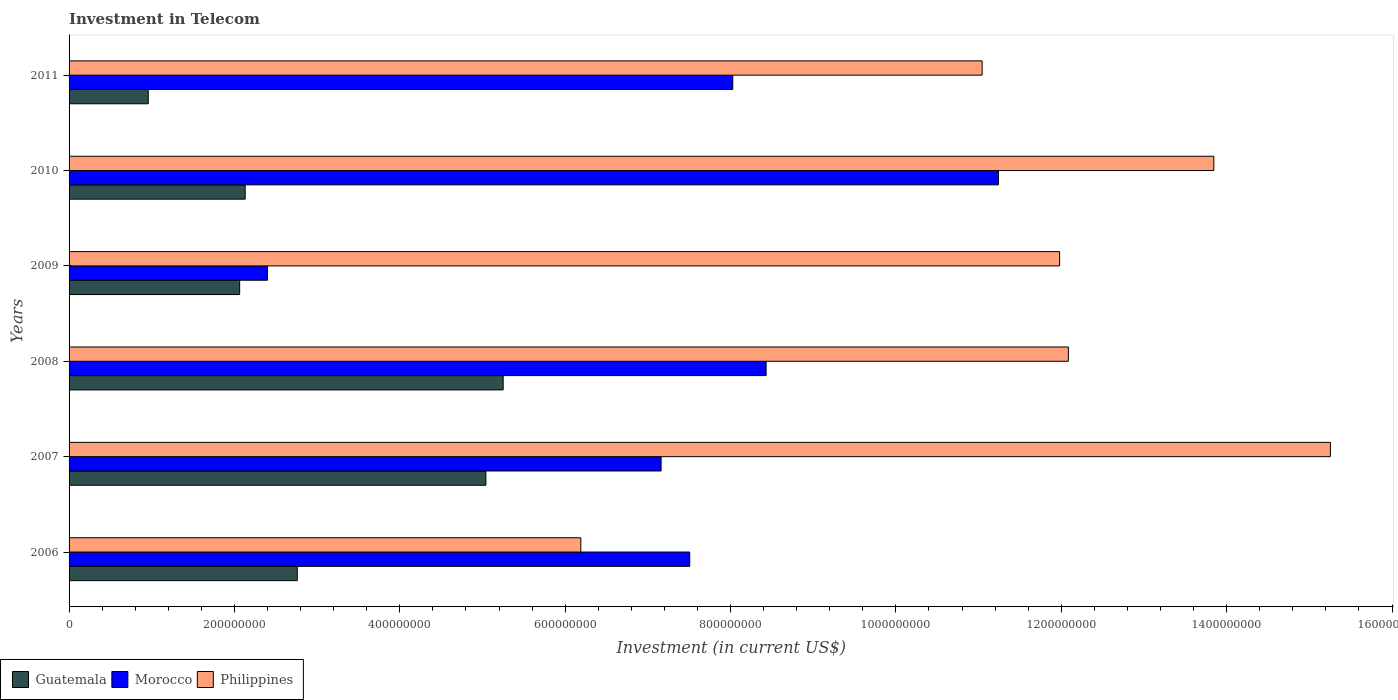Are the number of bars per tick equal to the number of legend labels?
Provide a short and direct response. Yes. How many bars are there on the 6th tick from the bottom?
Your response must be concise. 3. What is the label of the 3rd group of bars from the top?
Keep it short and to the point. 2009. In how many cases, is the number of bars for a given year not equal to the number of legend labels?
Provide a succinct answer. 0. What is the amount invested in telecom in Morocco in 2009?
Your answer should be compact. 2.40e+08. Across all years, what is the maximum amount invested in telecom in Philippines?
Your answer should be very brief. 1.53e+09. Across all years, what is the minimum amount invested in telecom in Morocco?
Provide a succinct answer. 2.40e+08. In which year was the amount invested in telecom in Philippines minimum?
Your answer should be compact. 2006. What is the total amount invested in telecom in Morocco in the graph?
Offer a very short reply. 4.48e+09. What is the difference between the amount invested in telecom in Philippines in 2010 and that in 2011?
Keep it short and to the point. 2.80e+08. What is the difference between the amount invested in telecom in Philippines in 2009 and the amount invested in telecom in Morocco in 2008?
Your response must be concise. 3.55e+08. What is the average amount invested in telecom in Morocco per year?
Keep it short and to the point. 7.46e+08. In the year 2006, what is the difference between the amount invested in telecom in Guatemala and amount invested in telecom in Morocco?
Offer a very short reply. -4.75e+08. In how many years, is the amount invested in telecom in Morocco greater than 1400000000 US$?
Keep it short and to the point. 0. What is the ratio of the amount invested in telecom in Guatemala in 2006 to that in 2007?
Your answer should be very brief. 0.55. Is the amount invested in telecom in Philippines in 2008 less than that in 2009?
Provide a short and direct response. No. What is the difference between the highest and the second highest amount invested in telecom in Guatemala?
Offer a very short reply. 2.09e+07. What is the difference between the highest and the lowest amount invested in telecom in Guatemala?
Your response must be concise. 4.29e+08. In how many years, is the amount invested in telecom in Philippines greater than the average amount invested in telecom in Philippines taken over all years?
Provide a succinct answer. 4. Is the sum of the amount invested in telecom in Morocco in 2008 and 2010 greater than the maximum amount invested in telecom in Guatemala across all years?
Provide a short and direct response. Yes. What does the 2nd bar from the top in 2007 represents?
Give a very brief answer. Morocco. What does the 1st bar from the bottom in 2009 represents?
Offer a terse response. Guatemala. How many bars are there?
Keep it short and to the point. 18. Are all the bars in the graph horizontal?
Keep it short and to the point. Yes. How many years are there in the graph?
Ensure brevity in your answer.  6. What is the difference between two consecutive major ticks on the X-axis?
Your answer should be very brief. 2.00e+08. Are the values on the major ticks of X-axis written in scientific E-notation?
Ensure brevity in your answer.  No. Does the graph contain any zero values?
Make the answer very short. No. Does the graph contain grids?
Your response must be concise. No. Where does the legend appear in the graph?
Your answer should be very brief. Bottom left. How are the legend labels stacked?
Your answer should be very brief. Horizontal. What is the title of the graph?
Your answer should be very brief. Investment in Telecom. Does "San Marino" appear as one of the legend labels in the graph?
Your answer should be very brief. No. What is the label or title of the X-axis?
Your response must be concise. Investment (in current US$). What is the Investment (in current US$) in Guatemala in 2006?
Make the answer very short. 2.76e+08. What is the Investment (in current US$) in Morocco in 2006?
Keep it short and to the point. 7.51e+08. What is the Investment (in current US$) of Philippines in 2006?
Provide a succinct answer. 6.19e+08. What is the Investment (in current US$) in Guatemala in 2007?
Make the answer very short. 5.04e+08. What is the Investment (in current US$) of Morocco in 2007?
Ensure brevity in your answer.  7.16e+08. What is the Investment (in current US$) of Philippines in 2007?
Your answer should be compact. 1.53e+09. What is the Investment (in current US$) in Guatemala in 2008?
Your answer should be compact. 5.25e+08. What is the Investment (in current US$) of Morocco in 2008?
Ensure brevity in your answer.  8.43e+08. What is the Investment (in current US$) of Philippines in 2008?
Provide a succinct answer. 1.21e+09. What is the Investment (in current US$) of Guatemala in 2009?
Provide a succinct answer. 2.06e+08. What is the Investment (in current US$) of Morocco in 2009?
Ensure brevity in your answer.  2.40e+08. What is the Investment (in current US$) in Philippines in 2009?
Provide a succinct answer. 1.20e+09. What is the Investment (in current US$) in Guatemala in 2010?
Ensure brevity in your answer.  2.13e+08. What is the Investment (in current US$) of Morocco in 2010?
Your answer should be very brief. 1.12e+09. What is the Investment (in current US$) of Philippines in 2010?
Ensure brevity in your answer.  1.38e+09. What is the Investment (in current US$) of Guatemala in 2011?
Give a very brief answer. 9.58e+07. What is the Investment (in current US$) of Morocco in 2011?
Ensure brevity in your answer.  8.03e+08. What is the Investment (in current US$) in Philippines in 2011?
Provide a short and direct response. 1.10e+09. Across all years, what is the maximum Investment (in current US$) of Guatemala?
Ensure brevity in your answer.  5.25e+08. Across all years, what is the maximum Investment (in current US$) of Morocco?
Offer a very short reply. 1.12e+09. Across all years, what is the maximum Investment (in current US$) in Philippines?
Your answer should be compact. 1.53e+09. Across all years, what is the minimum Investment (in current US$) in Guatemala?
Make the answer very short. 9.58e+07. Across all years, what is the minimum Investment (in current US$) in Morocco?
Keep it short and to the point. 2.40e+08. Across all years, what is the minimum Investment (in current US$) of Philippines?
Make the answer very short. 6.19e+08. What is the total Investment (in current US$) of Guatemala in the graph?
Your answer should be compact. 1.82e+09. What is the total Investment (in current US$) in Morocco in the graph?
Ensure brevity in your answer.  4.48e+09. What is the total Investment (in current US$) of Philippines in the graph?
Your answer should be very brief. 7.04e+09. What is the difference between the Investment (in current US$) in Guatemala in 2006 and that in 2007?
Provide a short and direct response. -2.28e+08. What is the difference between the Investment (in current US$) of Morocco in 2006 and that in 2007?
Make the answer very short. 3.46e+07. What is the difference between the Investment (in current US$) in Philippines in 2006 and that in 2007?
Offer a very short reply. -9.07e+08. What is the difference between the Investment (in current US$) of Guatemala in 2006 and that in 2008?
Make the answer very short. -2.49e+08. What is the difference between the Investment (in current US$) of Morocco in 2006 and that in 2008?
Offer a terse response. -9.24e+07. What is the difference between the Investment (in current US$) of Philippines in 2006 and that in 2008?
Your response must be concise. -5.90e+08. What is the difference between the Investment (in current US$) in Guatemala in 2006 and that in 2009?
Keep it short and to the point. 6.97e+07. What is the difference between the Investment (in current US$) of Morocco in 2006 and that in 2009?
Give a very brief answer. 5.11e+08. What is the difference between the Investment (in current US$) of Philippines in 2006 and that in 2009?
Offer a very short reply. -5.79e+08. What is the difference between the Investment (in current US$) of Guatemala in 2006 and that in 2010?
Your answer should be compact. 6.30e+07. What is the difference between the Investment (in current US$) in Morocco in 2006 and that in 2010?
Provide a succinct answer. -3.73e+08. What is the difference between the Investment (in current US$) of Philippines in 2006 and that in 2010?
Keep it short and to the point. -7.66e+08. What is the difference between the Investment (in current US$) of Guatemala in 2006 and that in 2011?
Ensure brevity in your answer.  1.80e+08. What is the difference between the Investment (in current US$) of Morocco in 2006 and that in 2011?
Offer a terse response. -5.21e+07. What is the difference between the Investment (in current US$) in Philippines in 2006 and that in 2011?
Make the answer very short. -4.85e+08. What is the difference between the Investment (in current US$) in Guatemala in 2007 and that in 2008?
Offer a terse response. -2.09e+07. What is the difference between the Investment (in current US$) in Morocco in 2007 and that in 2008?
Give a very brief answer. -1.27e+08. What is the difference between the Investment (in current US$) of Philippines in 2007 and that in 2008?
Offer a terse response. 3.17e+08. What is the difference between the Investment (in current US$) of Guatemala in 2007 and that in 2009?
Ensure brevity in your answer.  2.98e+08. What is the difference between the Investment (in current US$) of Morocco in 2007 and that in 2009?
Provide a succinct answer. 4.76e+08. What is the difference between the Investment (in current US$) of Philippines in 2007 and that in 2009?
Provide a succinct answer. 3.28e+08. What is the difference between the Investment (in current US$) in Guatemala in 2007 and that in 2010?
Provide a succinct answer. 2.91e+08. What is the difference between the Investment (in current US$) of Morocco in 2007 and that in 2010?
Provide a short and direct response. -4.08e+08. What is the difference between the Investment (in current US$) in Philippines in 2007 and that in 2010?
Give a very brief answer. 1.41e+08. What is the difference between the Investment (in current US$) of Guatemala in 2007 and that in 2011?
Ensure brevity in your answer.  4.08e+08. What is the difference between the Investment (in current US$) in Morocco in 2007 and that in 2011?
Provide a short and direct response. -8.67e+07. What is the difference between the Investment (in current US$) of Philippines in 2007 and that in 2011?
Ensure brevity in your answer.  4.21e+08. What is the difference between the Investment (in current US$) in Guatemala in 2008 and that in 2009?
Your response must be concise. 3.19e+08. What is the difference between the Investment (in current US$) in Morocco in 2008 and that in 2009?
Offer a terse response. 6.03e+08. What is the difference between the Investment (in current US$) in Philippines in 2008 and that in 2009?
Your response must be concise. 1.06e+07. What is the difference between the Investment (in current US$) of Guatemala in 2008 and that in 2010?
Offer a terse response. 3.12e+08. What is the difference between the Investment (in current US$) of Morocco in 2008 and that in 2010?
Keep it short and to the point. -2.81e+08. What is the difference between the Investment (in current US$) in Philippines in 2008 and that in 2010?
Your answer should be very brief. -1.76e+08. What is the difference between the Investment (in current US$) in Guatemala in 2008 and that in 2011?
Your answer should be compact. 4.29e+08. What is the difference between the Investment (in current US$) in Morocco in 2008 and that in 2011?
Give a very brief answer. 4.03e+07. What is the difference between the Investment (in current US$) of Philippines in 2008 and that in 2011?
Give a very brief answer. 1.04e+08. What is the difference between the Investment (in current US$) in Guatemala in 2009 and that in 2010?
Keep it short and to the point. -6.70e+06. What is the difference between the Investment (in current US$) of Morocco in 2009 and that in 2010?
Your response must be concise. -8.84e+08. What is the difference between the Investment (in current US$) of Philippines in 2009 and that in 2010?
Offer a terse response. -1.86e+08. What is the difference between the Investment (in current US$) of Guatemala in 2009 and that in 2011?
Your answer should be compact. 1.10e+08. What is the difference between the Investment (in current US$) in Morocco in 2009 and that in 2011?
Provide a short and direct response. -5.63e+08. What is the difference between the Investment (in current US$) of Philippines in 2009 and that in 2011?
Ensure brevity in your answer.  9.37e+07. What is the difference between the Investment (in current US$) in Guatemala in 2010 and that in 2011?
Provide a short and direct response. 1.17e+08. What is the difference between the Investment (in current US$) in Morocco in 2010 and that in 2011?
Your answer should be very brief. 3.21e+08. What is the difference between the Investment (in current US$) in Philippines in 2010 and that in 2011?
Ensure brevity in your answer.  2.80e+08. What is the difference between the Investment (in current US$) of Guatemala in 2006 and the Investment (in current US$) of Morocco in 2007?
Offer a very short reply. -4.40e+08. What is the difference between the Investment (in current US$) of Guatemala in 2006 and the Investment (in current US$) of Philippines in 2007?
Offer a very short reply. -1.25e+09. What is the difference between the Investment (in current US$) of Morocco in 2006 and the Investment (in current US$) of Philippines in 2007?
Provide a short and direct response. -7.75e+08. What is the difference between the Investment (in current US$) of Guatemala in 2006 and the Investment (in current US$) of Morocco in 2008?
Offer a very short reply. -5.67e+08. What is the difference between the Investment (in current US$) in Guatemala in 2006 and the Investment (in current US$) in Philippines in 2008?
Keep it short and to the point. -9.33e+08. What is the difference between the Investment (in current US$) in Morocco in 2006 and the Investment (in current US$) in Philippines in 2008?
Provide a short and direct response. -4.58e+08. What is the difference between the Investment (in current US$) of Guatemala in 2006 and the Investment (in current US$) of Morocco in 2009?
Your answer should be compact. 3.60e+07. What is the difference between the Investment (in current US$) of Guatemala in 2006 and the Investment (in current US$) of Philippines in 2009?
Keep it short and to the point. -9.22e+08. What is the difference between the Investment (in current US$) of Morocco in 2006 and the Investment (in current US$) of Philippines in 2009?
Give a very brief answer. -4.47e+08. What is the difference between the Investment (in current US$) in Guatemala in 2006 and the Investment (in current US$) in Morocco in 2010?
Offer a very short reply. -8.48e+08. What is the difference between the Investment (in current US$) of Guatemala in 2006 and the Investment (in current US$) of Philippines in 2010?
Your response must be concise. -1.11e+09. What is the difference between the Investment (in current US$) of Morocco in 2006 and the Investment (in current US$) of Philippines in 2010?
Provide a succinct answer. -6.34e+08. What is the difference between the Investment (in current US$) of Guatemala in 2006 and the Investment (in current US$) of Morocco in 2011?
Give a very brief answer. -5.27e+08. What is the difference between the Investment (in current US$) in Guatemala in 2006 and the Investment (in current US$) in Philippines in 2011?
Your answer should be compact. -8.28e+08. What is the difference between the Investment (in current US$) in Morocco in 2006 and the Investment (in current US$) in Philippines in 2011?
Your answer should be very brief. -3.54e+08. What is the difference between the Investment (in current US$) in Guatemala in 2007 and the Investment (in current US$) in Morocco in 2008?
Provide a succinct answer. -3.39e+08. What is the difference between the Investment (in current US$) in Guatemala in 2007 and the Investment (in current US$) in Philippines in 2008?
Your answer should be compact. -7.04e+08. What is the difference between the Investment (in current US$) in Morocco in 2007 and the Investment (in current US$) in Philippines in 2008?
Make the answer very short. -4.93e+08. What is the difference between the Investment (in current US$) of Guatemala in 2007 and the Investment (in current US$) of Morocco in 2009?
Provide a short and direct response. 2.64e+08. What is the difference between the Investment (in current US$) of Guatemala in 2007 and the Investment (in current US$) of Philippines in 2009?
Your response must be concise. -6.94e+08. What is the difference between the Investment (in current US$) of Morocco in 2007 and the Investment (in current US$) of Philippines in 2009?
Provide a succinct answer. -4.82e+08. What is the difference between the Investment (in current US$) of Guatemala in 2007 and the Investment (in current US$) of Morocco in 2010?
Ensure brevity in your answer.  -6.20e+08. What is the difference between the Investment (in current US$) in Guatemala in 2007 and the Investment (in current US$) in Philippines in 2010?
Keep it short and to the point. -8.80e+08. What is the difference between the Investment (in current US$) in Morocco in 2007 and the Investment (in current US$) in Philippines in 2010?
Your answer should be compact. -6.68e+08. What is the difference between the Investment (in current US$) in Guatemala in 2007 and the Investment (in current US$) in Morocco in 2011?
Keep it short and to the point. -2.99e+08. What is the difference between the Investment (in current US$) in Guatemala in 2007 and the Investment (in current US$) in Philippines in 2011?
Give a very brief answer. -6.00e+08. What is the difference between the Investment (in current US$) in Morocco in 2007 and the Investment (in current US$) in Philippines in 2011?
Your answer should be compact. -3.88e+08. What is the difference between the Investment (in current US$) of Guatemala in 2008 and the Investment (in current US$) of Morocco in 2009?
Ensure brevity in your answer.  2.85e+08. What is the difference between the Investment (in current US$) of Guatemala in 2008 and the Investment (in current US$) of Philippines in 2009?
Provide a succinct answer. -6.73e+08. What is the difference between the Investment (in current US$) of Morocco in 2008 and the Investment (in current US$) of Philippines in 2009?
Ensure brevity in your answer.  -3.55e+08. What is the difference between the Investment (in current US$) in Guatemala in 2008 and the Investment (in current US$) in Morocco in 2010?
Make the answer very short. -5.99e+08. What is the difference between the Investment (in current US$) in Guatemala in 2008 and the Investment (in current US$) in Philippines in 2010?
Offer a very short reply. -8.60e+08. What is the difference between the Investment (in current US$) of Morocco in 2008 and the Investment (in current US$) of Philippines in 2010?
Provide a short and direct response. -5.42e+08. What is the difference between the Investment (in current US$) of Guatemala in 2008 and the Investment (in current US$) of Morocco in 2011?
Offer a terse response. -2.78e+08. What is the difference between the Investment (in current US$) in Guatemala in 2008 and the Investment (in current US$) in Philippines in 2011?
Your response must be concise. -5.79e+08. What is the difference between the Investment (in current US$) in Morocco in 2008 and the Investment (in current US$) in Philippines in 2011?
Your answer should be compact. -2.61e+08. What is the difference between the Investment (in current US$) of Guatemala in 2009 and the Investment (in current US$) of Morocco in 2010?
Keep it short and to the point. -9.18e+08. What is the difference between the Investment (in current US$) in Guatemala in 2009 and the Investment (in current US$) in Philippines in 2010?
Your answer should be very brief. -1.18e+09. What is the difference between the Investment (in current US$) of Morocco in 2009 and the Investment (in current US$) of Philippines in 2010?
Keep it short and to the point. -1.14e+09. What is the difference between the Investment (in current US$) of Guatemala in 2009 and the Investment (in current US$) of Morocco in 2011?
Your answer should be very brief. -5.96e+08. What is the difference between the Investment (in current US$) of Guatemala in 2009 and the Investment (in current US$) of Philippines in 2011?
Offer a very short reply. -8.98e+08. What is the difference between the Investment (in current US$) in Morocco in 2009 and the Investment (in current US$) in Philippines in 2011?
Your answer should be very brief. -8.64e+08. What is the difference between the Investment (in current US$) in Guatemala in 2010 and the Investment (in current US$) in Morocco in 2011?
Your answer should be compact. -5.90e+08. What is the difference between the Investment (in current US$) of Guatemala in 2010 and the Investment (in current US$) of Philippines in 2011?
Offer a terse response. -8.91e+08. What is the difference between the Investment (in current US$) of Morocco in 2010 and the Investment (in current US$) of Philippines in 2011?
Keep it short and to the point. 1.97e+07. What is the average Investment (in current US$) in Guatemala per year?
Give a very brief answer. 3.03e+08. What is the average Investment (in current US$) in Morocco per year?
Your response must be concise. 7.46e+08. What is the average Investment (in current US$) in Philippines per year?
Provide a succinct answer. 1.17e+09. In the year 2006, what is the difference between the Investment (in current US$) in Guatemala and Investment (in current US$) in Morocco?
Provide a short and direct response. -4.75e+08. In the year 2006, what is the difference between the Investment (in current US$) of Guatemala and Investment (in current US$) of Philippines?
Your answer should be compact. -3.43e+08. In the year 2006, what is the difference between the Investment (in current US$) of Morocco and Investment (in current US$) of Philippines?
Ensure brevity in your answer.  1.32e+08. In the year 2007, what is the difference between the Investment (in current US$) of Guatemala and Investment (in current US$) of Morocco?
Offer a very short reply. -2.12e+08. In the year 2007, what is the difference between the Investment (in current US$) of Guatemala and Investment (in current US$) of Philippines?
Provide a succinct answer. -1.02e+09. In the year 2007, what is the difference between the Investment (in current US$) in Morocco and Investment (in current US$) in Philippines?
Keep it short and to the point. -8.10e+08. In the year 2008, what is the difference between the Investment (in current US$) in Guatemala and Investment (in current US$) in Morocco?
Provide a short and direct response. -3.18e+08. In the year 2008, what is the difference between the Investment (in current US$) of Guatemala and Investment (in current US$) of Philippines?
Provide a succinct answer. -6.84e+08. In the year 2008, what is the difference between the Investment (in current US$) in Morocco and Investment (in current US$) in Philippines?
Provide a succinct answer. -3.66e+08. In the year 2009, what is the difference between the Investment (in current US$) in Guatemala and Investment (in current US$) in Morocco?
Make the answer very short. -3.37e+07. In the year 2009, what is the difference between the Investment (in current US$) of Guatemala and Investment (in current US$) of Philippines?
Your response must be concise. -9.92e+08. In the year 2009, what is the difference between the Investment (in current US$) of Morocco and Investment (in current US$) of Philippines?
Your answer should be compact. -9.58e+08. In the year 2010, what is the difference between the Investment (in current US$) in Guatemala and Investment (in current US$) in Morocco?
Your response must be concise. -9.11e+08. In the year 2010, what is the difference between the Investment (in current US$) of Guatemala and Investment (in current US$) of Philippines?
Offer a very short reply. -1.17e+09. In the year 2010, what is the difference between the Investment (in current US$) of Morocco and Investment (in current US$) of Philippines?
Provide a short and direct response. -2.60e+08. In the year 2011, what is the difference between the Investment (in current US$) in Guatemala and Investment (in current US$) in Morocco?
Your answer should be very brief. -7.07e+08. In the year 2011, what is the difference between the Investment (in current US$) in Guatemala and Investment (in current US$) in Philippines?
Provide a short and direct response. -1.01e+09. In the year 2011, what is the difference between the Investment (in current US$) in Morocco and Investment (in current US$) in Philippines?
Keep it short and to the point. -3.02e+08. What is the ratio of the Investment (in current US$) in Guatemala in 2006 to that in 2007?
Provide a short and direct response. 0.55. What is the ratio of the Investment (in current US$) in Morocco in 2006 to that in 2007?
Give a very brief answer. 1.05. What is the ratio of the Investment (in current US$) in Philippines in 2006 to that in 2007?
Your answer should be compact. 0.41. What is the ratio of the Investment (in current US$) in Guatemala in 2006 to that in 2008?
Offer a terse response. 0.53. What is the ratio of the Investment (in current US$) in Morocco in 2006 to that in 2008?
Offer a very short reply. 0.89. What is the ratio of the Investment (in current US$) of Philippines in 2006 to that in 2008?
Offer a very short reply. 0.51. What is the ratio of the Investment (in current US$) in Guatemala in 2006 to that in 2009?
Your response must be concise. 1.34. What is the ratio of the Investment (in current US$) in Morocco in 2006 to that in 2009?
Make the answer very short. 3.13. What is the ratio of the Investment (in current US$) of Philippines in 2006 to that in 2009?
Give a very brief answer. 0.52. What is the ratio of the Investment (in current US$) of Guatemala in 2006 to that in 2010?
Your answer should be very brief. 1.3. What is the ratio of the Investment (in current US$) of Morocco in 2006 to that in 2010?
Keep it short and to the point. 0.67. What is the ratio of the Investment (in current US$) in Philippines in 2006 to that in 2010?
Keep it short and to the point. 0.45. What is the ratio of the Investment (in current US$) in Guatemala in 2006 to that in 2011?
Provide a succinct answer. 2.88. What is the ratio of the Investment (in current US$) in Morocco in 2006 to that in 2011?
Offer a terse response. 0.94. What is the ratio of the Investment (in current US$) in Philippines in 2006 to that in 2011?
Offer a very short reply. 0.56. What is the ratio of the Investment (in current US$) of Guatemala in 2007 to that in 2008?
Ensure brevity in your answer.  0.96. What is the ratio of the Investment (in current US$) in Morocco in 2007 to that in 2008?
Give a very brief answer. 0.85. What is the ratio of the Investment (in current US$) of Philippines in 2007 to that in 2008?
Provide a short and direct response. 1.26. What is the ratio of the Investment (in current US$) of Guatemala in 2007 to that in 2009?
Offer a very short reply. 2.44. What is the ratio of the Investment (in current US$) in Morocco in 2007 to that in 2009?
Ensure brevity in your answer.  2.98. What is the ratio of the Investment (in current US$) in Philippines in 2007 to that in 2009?
Make the answer very short. 1.27. What is the ratio of the Investment (in current US$) of Guatemala in 2007 to that in 2010?
Provide a short and direct response. 2.37. What is the ratio of the Investment (in current US$) in Morocco in 2007 to that in 2010?
Your response must be concise. 0.64. What is the ratio of the Investment (in current US$) in Philippines in 2007 to that in 2010?
Provide a short and direct response. 1.1. What is the ratio of the Investment (in current US$) of Guatemala in 2007 to that in 2011?
Offer a very short reply. 5.26. What is the ratio of the Investment (in current US$) in Morocco in 2007 to that in 2011?
Give a very brief answer. 0.89. What is the ratio of the Investment (in current US$) of Philippines in 2007 to that in 2011?
Your answer should be compact. 1.38. What is the ratio of the Investment (in current US$) in Guatemala in 2008 to that in 2009?
Offer a very short reply. 2.54. What is the ratio of the Investment (in current US$) in Morocco in 2008 to that in 2009?
Keep it short and to the point. 3.51. What is the ratio of the Investment (in current US$) in Philippines in 2008 to that in 2009?
Your answer should be compact. 1.01. What is the ratio of the Investment (in current US$) in Guatemala in 2008 to that in 2010?
Offer a very short reply. 2.46. What is the ratio of the Investment (in current US$) in Morocco in 2008 to that in 2010?
Keep it short and to the point. 0.75. What is the ratio of the Investment (in current US$) in Philippines in 2008 to that in 2010?
Offer a terse response. 0.87. What is the ratio of the Investment (in current US$) of Guatemala in 2008 to that in 2011?
Your answer should be compact. 5.48. What is the ratio of the Investment (in current US$) of Morocco in 2008 to that in 2011?
Offer a terse response. 1.05. What is the ratio of the Investment (in current US$) of Philippines in 2008 to that in 2011?
Offer a very short reply. 1.09. What is the ratio of the Investment (in current US$) in Guatemala in 2009 to that in 2010?
Your answer should be very brief. 0.97. What is the ratio of the Investment (in current US$) of Morocco in 2009 to that in 2010?
Your response must be concise. 0.21. What is the ratio of the Investment (in current US$) of Philippines in 2009 to that in 2010?
Provide a short and direct response. 0.87. What is the ratio of the Investment (in current US$) of Guatemala in 2009 to that in 2011?
Your response must be concise. 2.15. What is the ratio of the Investment (in current US$) of Morocco in 2009 to that in 2011?
Offer a very short reply. 0.3. What is the ratio of the Investment (in current US$) in Philippines in 2009 to that in 2011?
Keep it short and to the point. 1.08. What is the ratio of the Investment (in current US$) of Guatemala in 2010 to that in 2011?
Keep it short and to the point. 2.22. What is the ratio of the Investment (in current US$) in Morocco in 2010 to that in 2011?
Your answer should be compact. 1.4. What is the ratio of the Investment (in current US$) in Philippines in 2010 to that in 2011?
Your answer should be very brief. 1.25. What is the difference between the highest and the second highest Investment (in current US$) of Guatemala?
Provide a short and direct response. 2.09e+07. What is the difference between the highest and the second highest Investment (in current US$) in Morocco?
Your answer should be very brief. 2.81e+08. What is the difference between the highest and the second highest Investment (in current US$) in Philippines?
Provide a succinct answer. 1.41e+08. What is the difference between the highest and the lowest Investment (in current US$) in Guatemala?
Your response must be concise. 4.29e+08. What is the difference between the highest and the lowest Investment (in current US$) of Morocco?
Make the answer very short. 8.84e+08. What is the difference between the highest and the lowest Investment (in current US$) in Philippines?
Provide a short and direct response. 9.07e+08. 